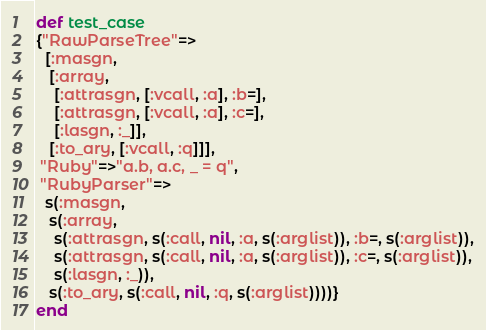<code> <loc_0><loc_0><loc_500><loc_500><_Ruby_>def test_case
{"RawParseTree"=>
  [:masgn,
   [:array,
    [:attrasgn, [:vcall, :a], :b=],
    [:attrasgn, [:vcall, :a], :c=],
    [:lasgn, :_]],
   [:to_ary, [:vcall, :q]]],
 "Ruby"=>"a.b, a.c, _ = q",
 "RubyParser"=>
  s(:masgn,
   s(:array,
    s(:attrasgn, s(:call, nil, :a, s(:arglist)), :b=, s(:arglist)),
    s(:attrasgn, s(:call, nil, :a, s(:arglist)), :c=, s(:arglist)),
    s(:lasgn, :_)),
   s(:to_ary, s(:call, nil, :q, s(:arglist))))}
end
</code> 